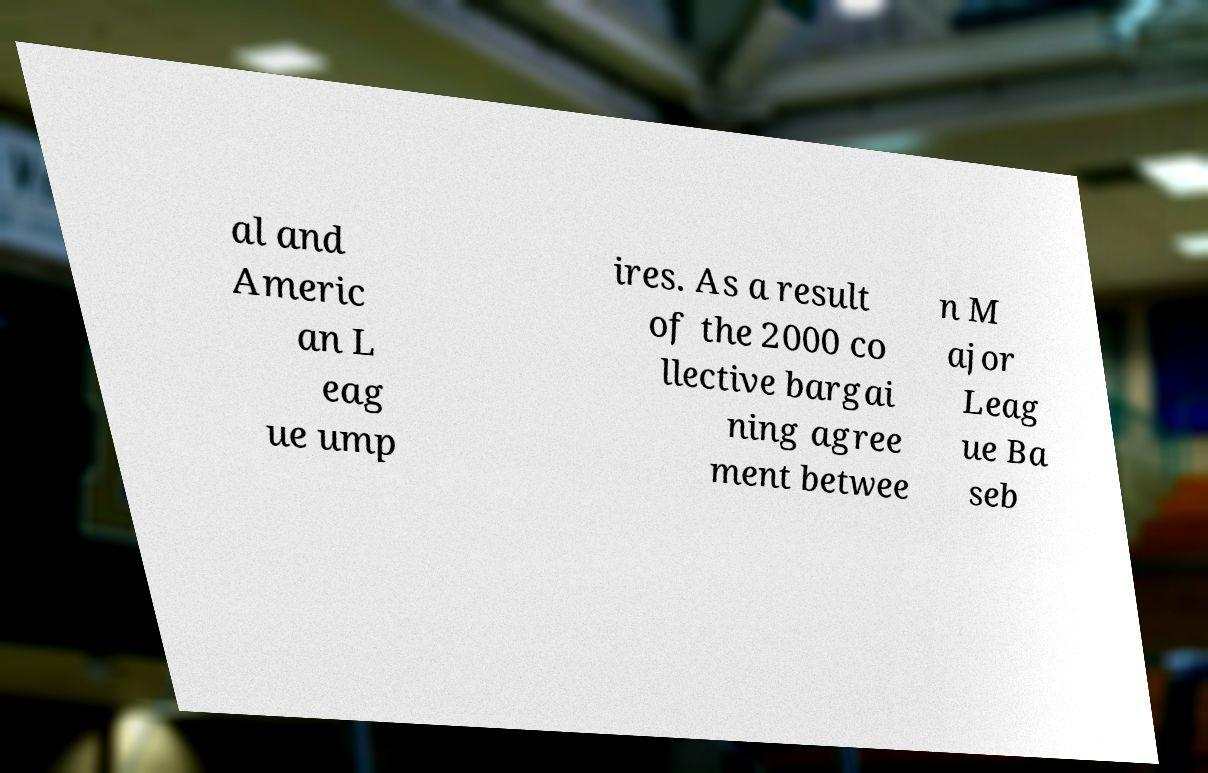Could you assist in decoding the text presented in this image and type it out clearly? al and Americ an L eag ue ump ires. As a result of the 2000 co llective bargai ning agree ment betwee n M ajor Leag ue Ba seb 